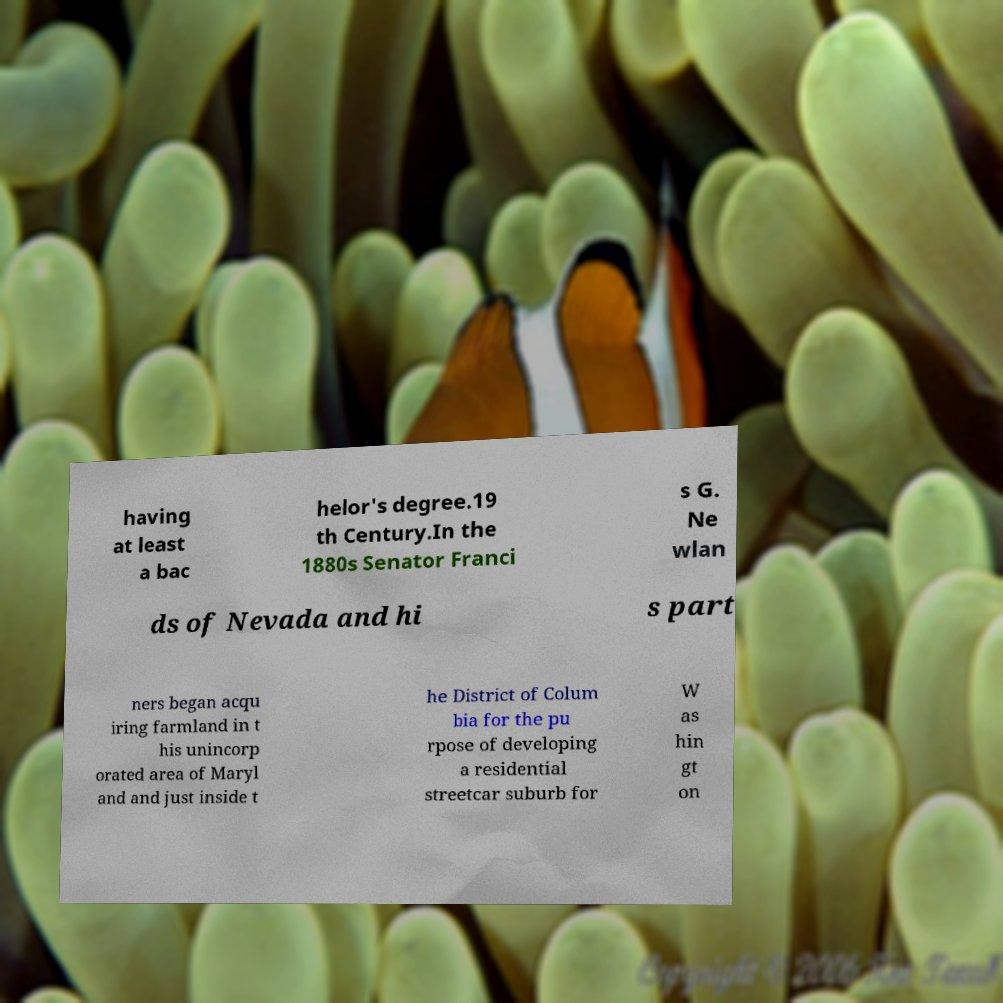I need the written content from this picture converted into text. Can you do that? having at least a bac helor's degree.19 th Century.In the 1880s Senator Franci s G. Ne wlan ds of Nevada and hi s part ners began acqu iring farmland in t his unincorp orated area of Maryl and and just inside t he District of Colum bia for the pu rpose of developing a residential streetcar suburb for W as hin gt on 